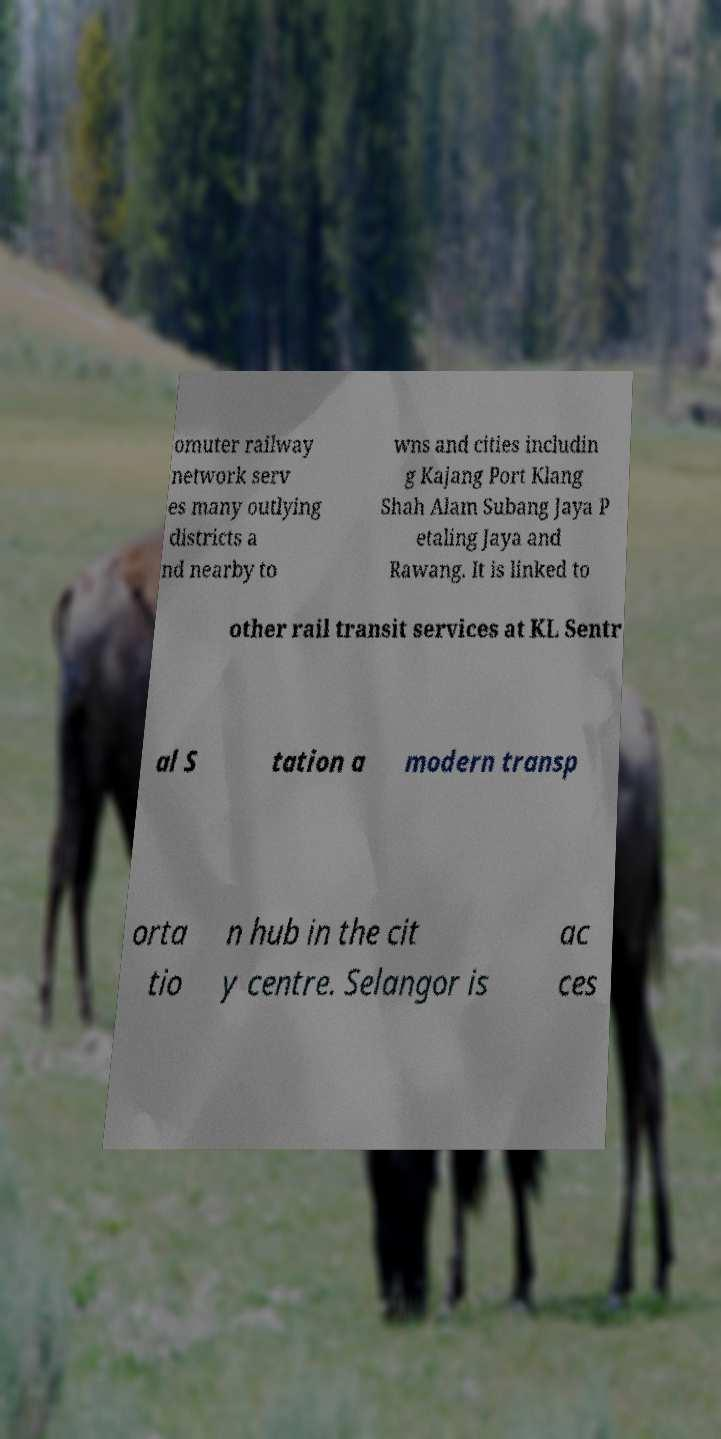For documentation purposes, I need the text within this image transcribed. Could you provide that? omuter railway network serv es many outlying districts a nd nearby to wns and cities includin g Kajang Port Klang Shah Alam Subang Jaya P etaling Jaya and Rawang. It is linked to other rail transit services at KL Sentr al S tation a modern transp orta tio n hub in the cit y centre. Selangor is ac ces 